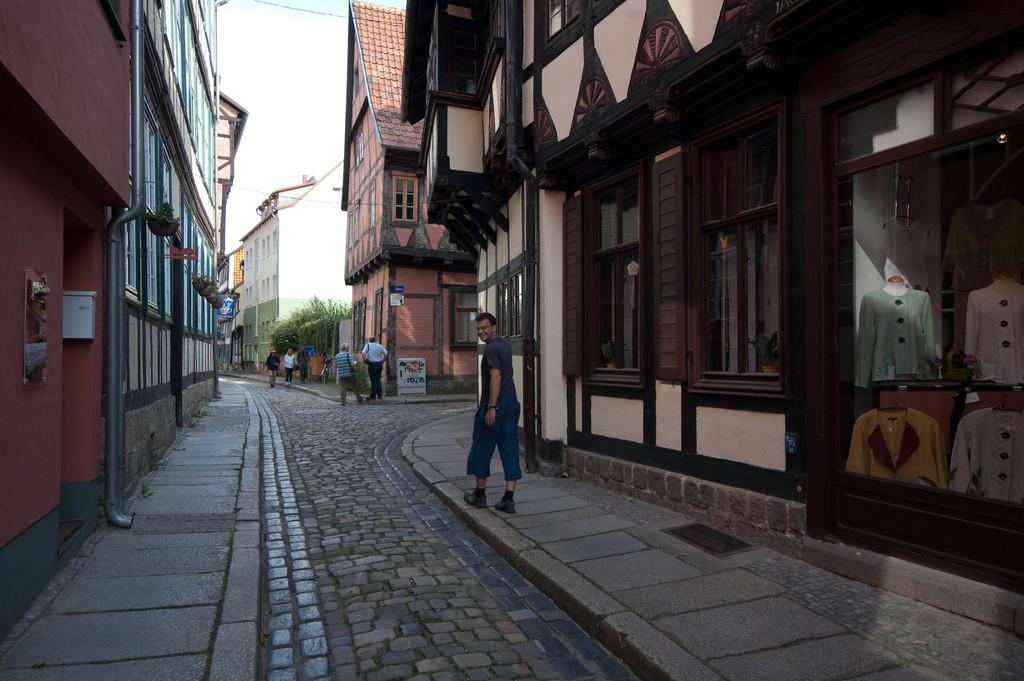What type of structures can be seen in the image? There are buildings in the image. What other natural elements are present in the image? There are trees in the image. Are there any signs or notices visible in the image? Yes, there are boards with text in the image. What are the people in the image doing? People are walking in the image. What can be seen through the glass in the image? There are mannequins with clothes visible through a glass. How would you describe the weather in the image? The sky is cloudy in the image. What type of bulb is being used by the sister to stimulate the nerve in the image? There is no mention of a bulb, sister, or nerve in the image. 